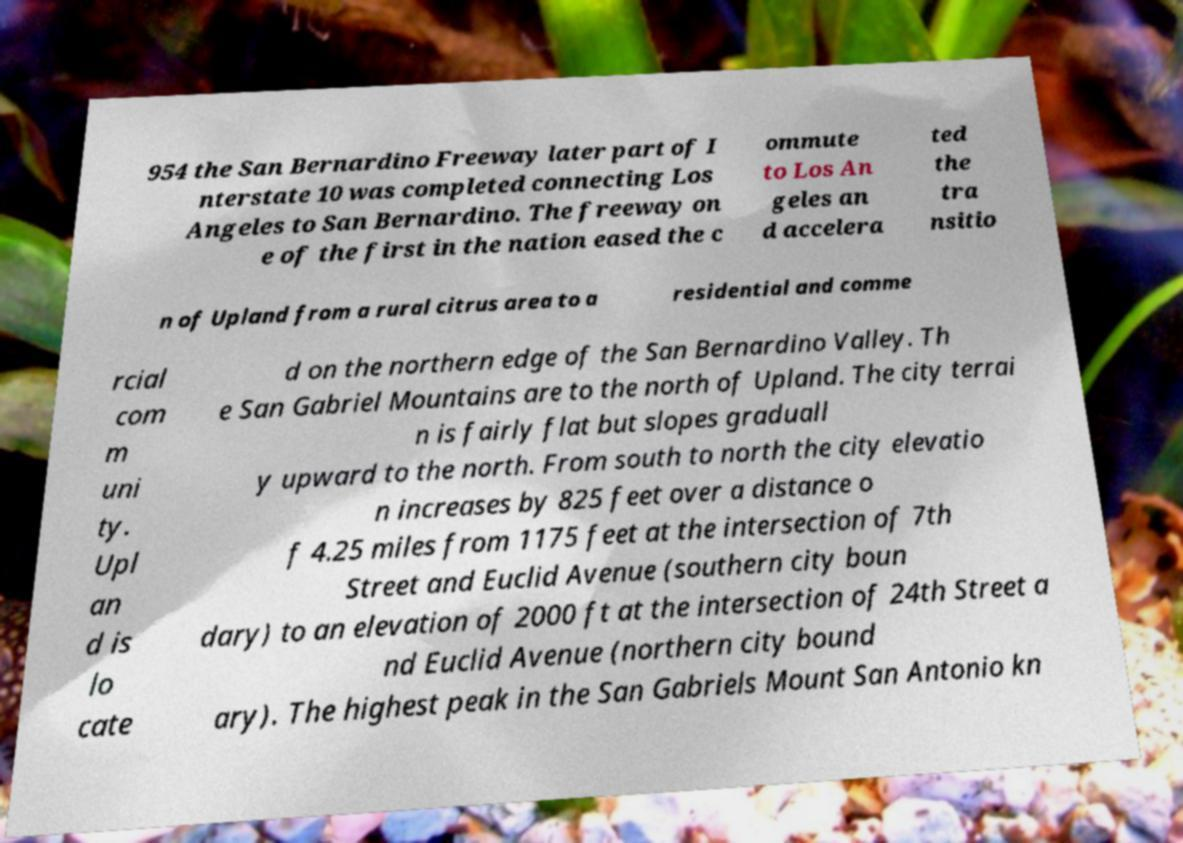For documentation purposes, I need the text within this image transcribed. Could you provide that? 954 the San Bernardino Freeway later part of I nterstate 10 was completed connecting Los Angeles to San Bernardino. The freeway on e of the first in the nation eased the c ommute to Los An geles an d accelera ted the tra nsitio n of Upland from a rural citrus area to a residential and comme rcial com m uni ty. Upl an d is lo cate d on the northern edge of the San Bernardino Valley. Th e San Gabriel Mountains are to the north of Upland. The city terrai n is fairly flat but slopes graduall y upward to the north. From south to north the city elevatio n increases by 825 feet over a distance o f 4.25 miles from 1175 feet at the intersection of 7th Street and Euclid Avenue (southern city boun dary) to an elevation of 2000 ft at the intersection of 24th Street a nd Euclid Avenue (northern city bound ary). The highest peak in the San Gabriels Mount San Antonio kn 